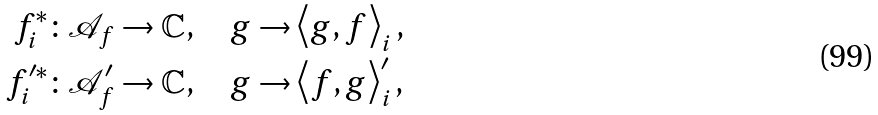<formula> <loc_0><loc_0><loc_500><loc_500>f _ { i } ^ { \ast } & \colon \mathcal { A } _ { f } \rightarrow \mathbb { C } , \quad g \rightarrow \left \langle g , f \right \rangle _ { i } , \\ f _ { i } ^ { \prime \ast } & \colon \mathcal { A } _ { f } ^ { \prime } \rightarrow \mathbb { C } , \quad g \rightarrow \left \langle f , g \right \rangle _ { i } ^ { \prime } ,</formula> 